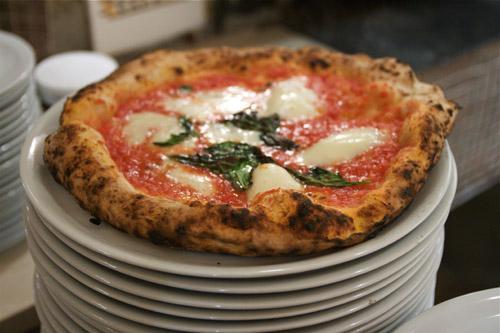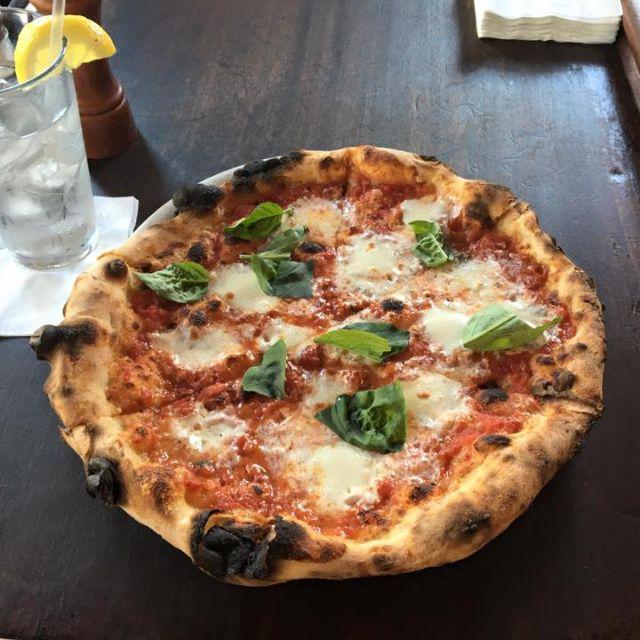The first image is the image on the left, the second image is the image on the right. Examine the images to the left and right. Is the description "In at least one image the is a small piece of pizza with toppings sit on top of a circle white plate." accurate? Answer yes or no. Yes. The first image is the image on the left, the second image is the image on the right. For the images displayed, is the sentence "A whole cooked pizza is on a white plate." factually correct? Answer yes or no. Yes. 